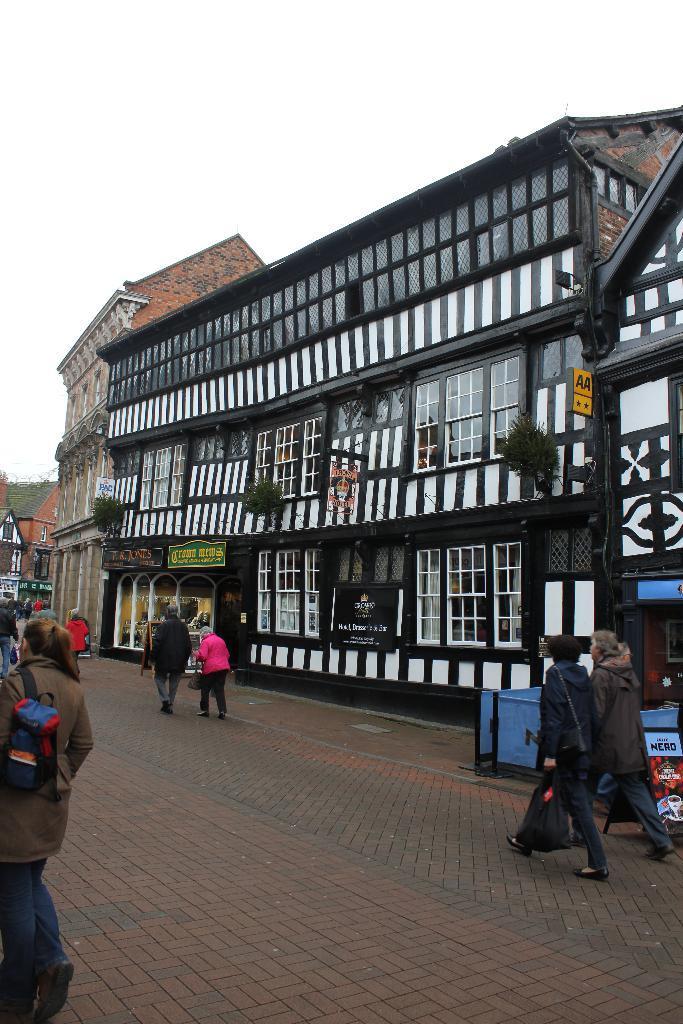How would you summarize this image in a sentence or two? In this image I can see few people are holding bags and walking on the road. Back Side I can see buildings and windows. I can see stores,boards and trees. The sky is in white color. 